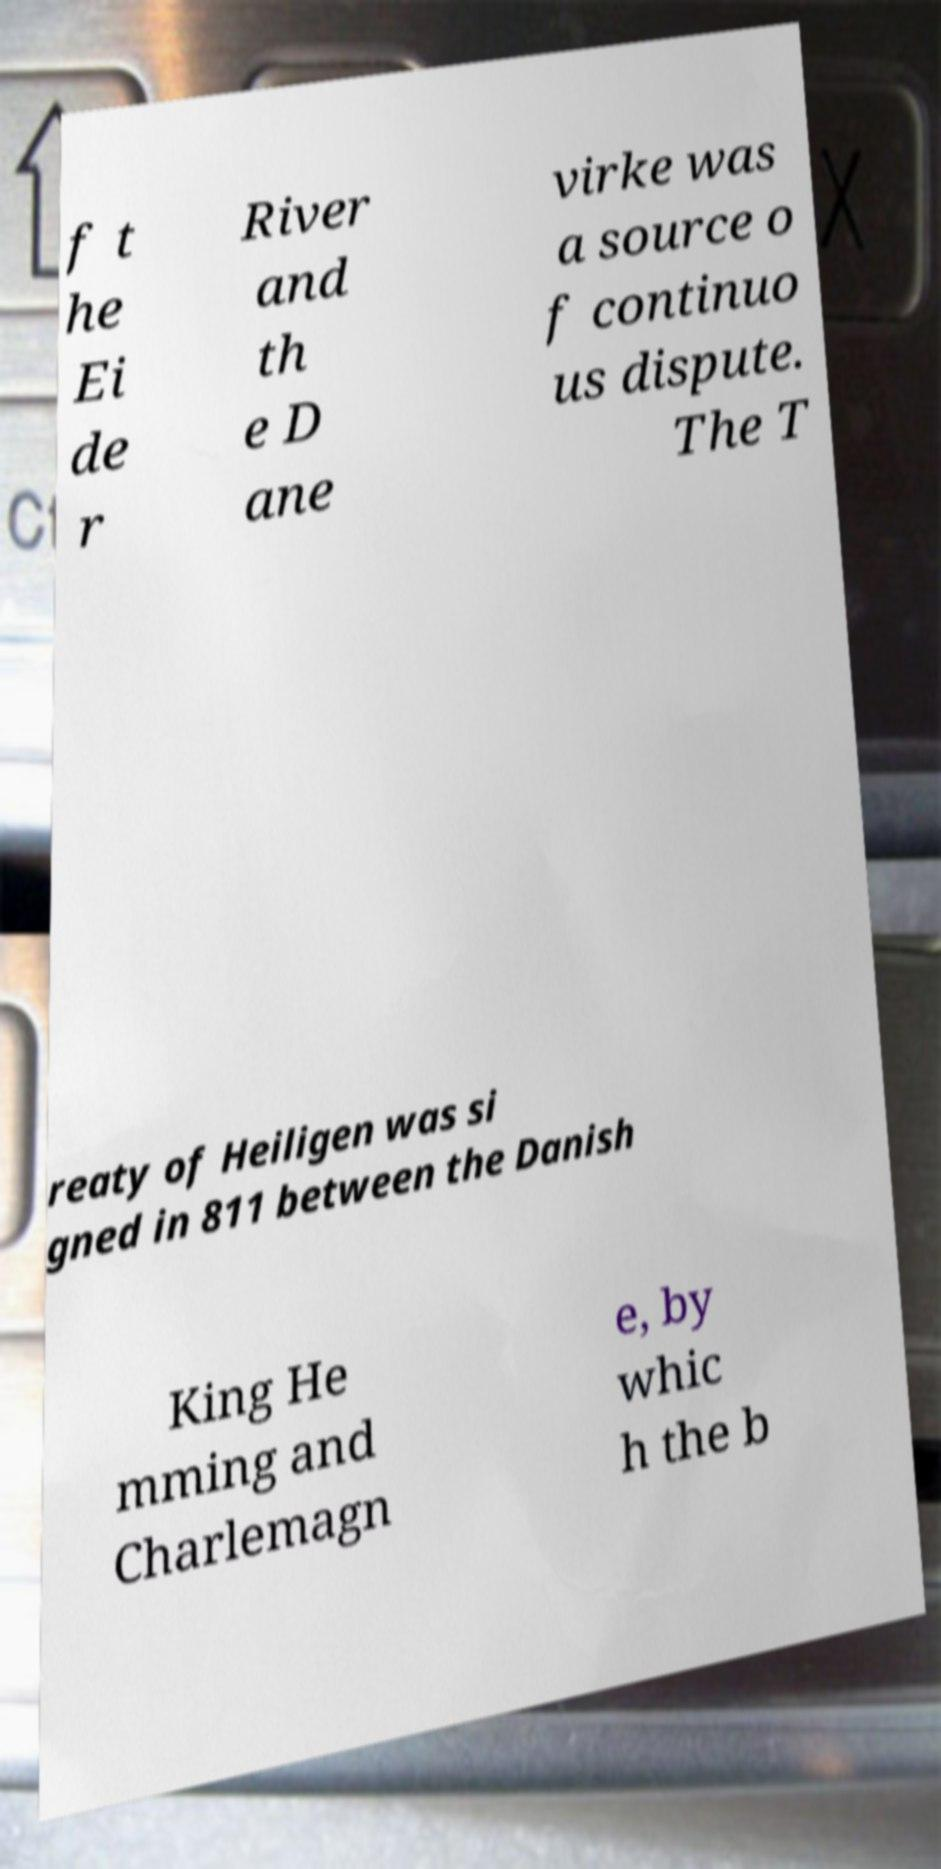Please read and relay the text visible in this image. What does it say? f t he Ei de r River and th e D ane virke was a source o f continuo us dispute. The T reaty of Heiligen was si gned in 811 between the Danish King He mming and Charlemagn e, by whic h the b 